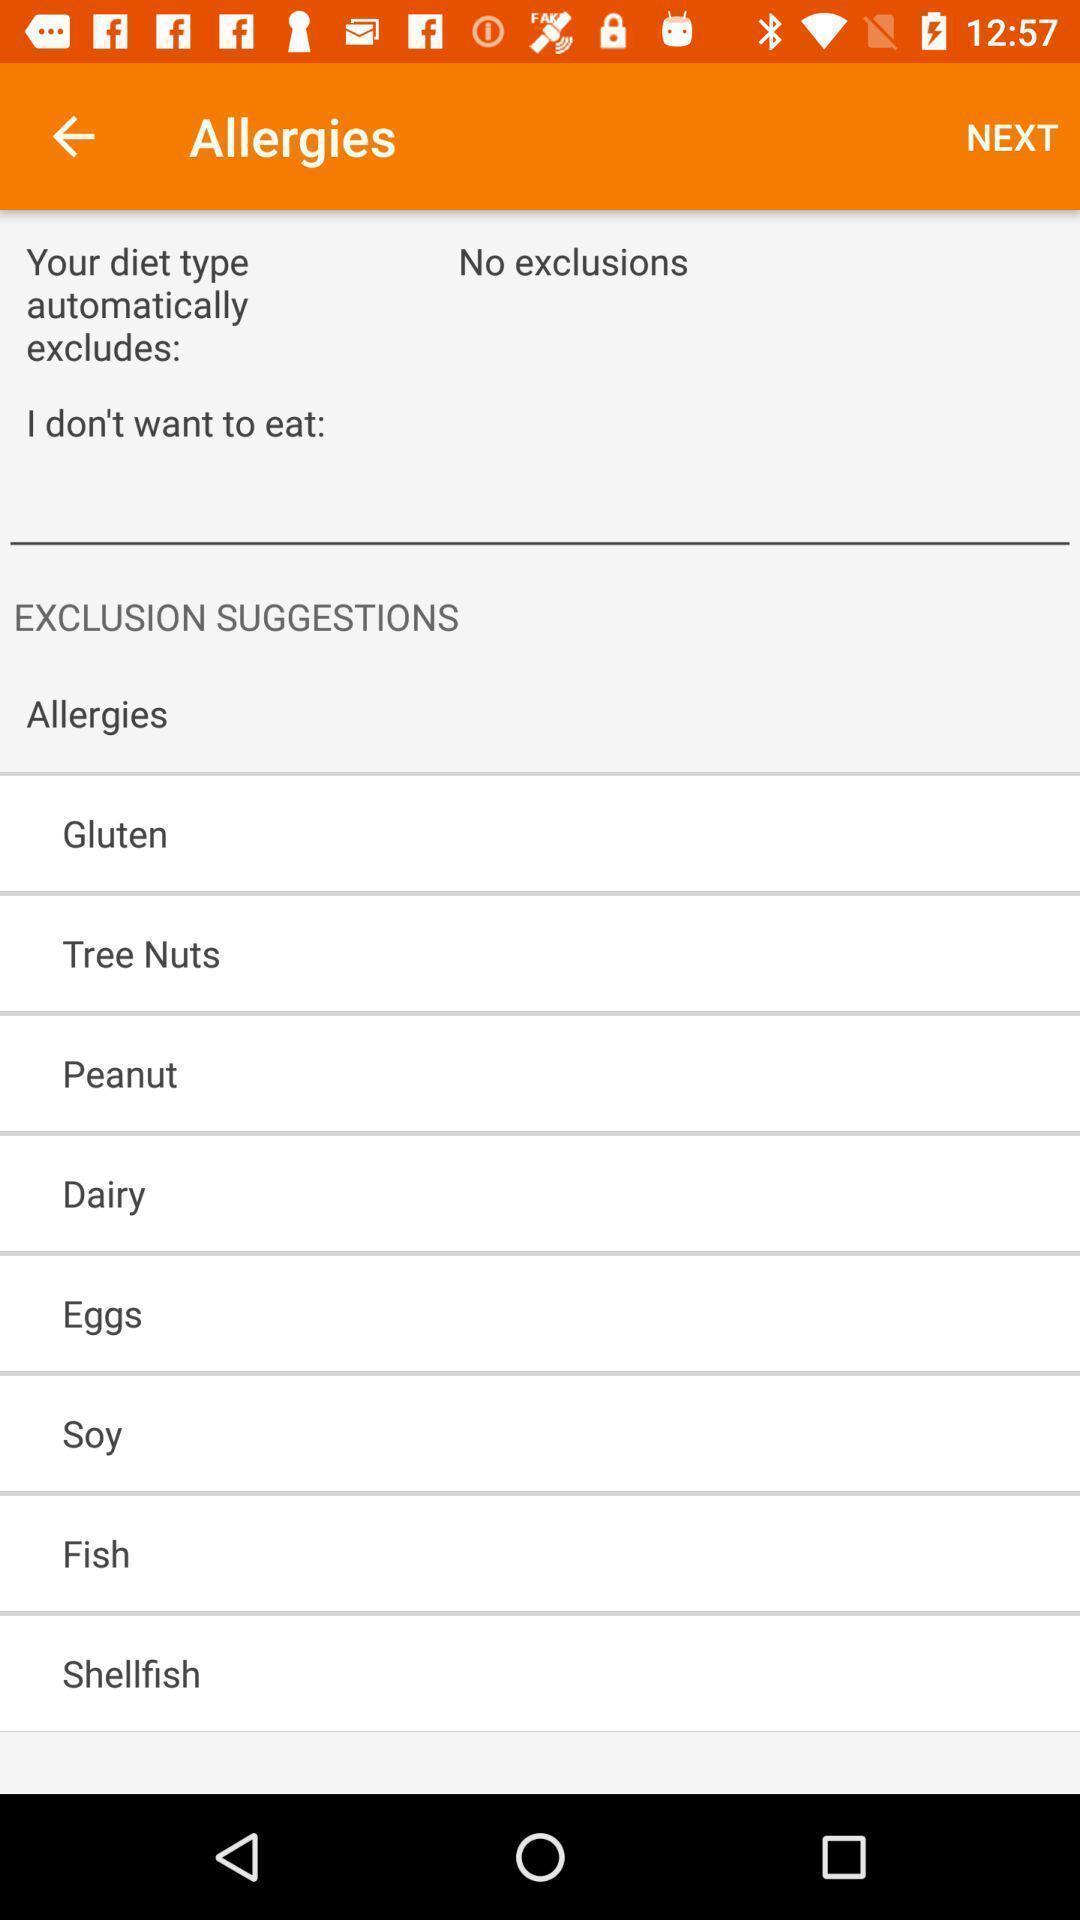What can you discern from this picture? Types of allergies in medical app. 